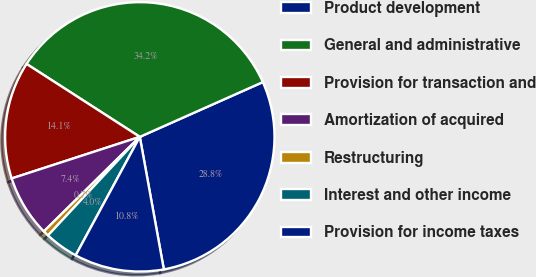Convert chart. <chart><loc_0><loc_0><loc_500><loc_500><pie_chart><fcel>Product development<fcel>General and administrative<fcel>Provision for transaction and<fcel>Amortization of acquired<fcel>Restructuring<fcel>Interest and other income<fcel>Provision for income taxes<nl><fcel>28.81%<fcel>34.23%<fcel>14.1%<fcel>7.39%<fcel>0.68%<fcel>4.04%<fcel>10.75%<nl></chart> 